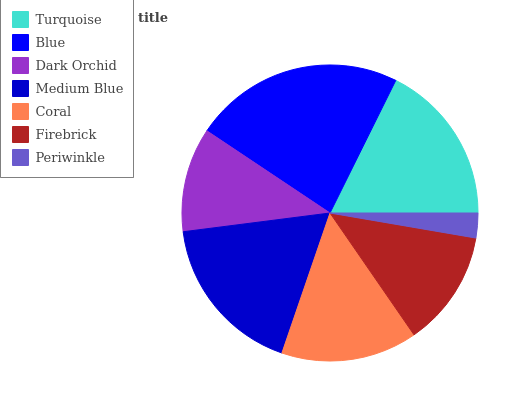Is Periwinkle the minimum?
Answer yes or no. Yes. Is Blue the maximum?
Answer yes or no. Yes. Is Dark Orchid the minimum?
Answer yes or no. No. Is Dark Orchid the maximum?
Answer yes or no. No. Is Blue greater than Dark Orchid?
Answer yes or no. Yes. Is Dark Orchid less than Blue?
Answer yes or no. Yes. Is Dark Orchid greater than Blue?
Answer yes or no. No. Is Blue less than Dark Orchid?
Answer yes or no. No. Is Coral the high median?
Answer yes or no. Yes. Is Coral the low median?
Answer yes or no. Yes. Is Blue the high median?
Answer yes or no. No. Is Medium Blue the low median?
Answer yes or no. No. 